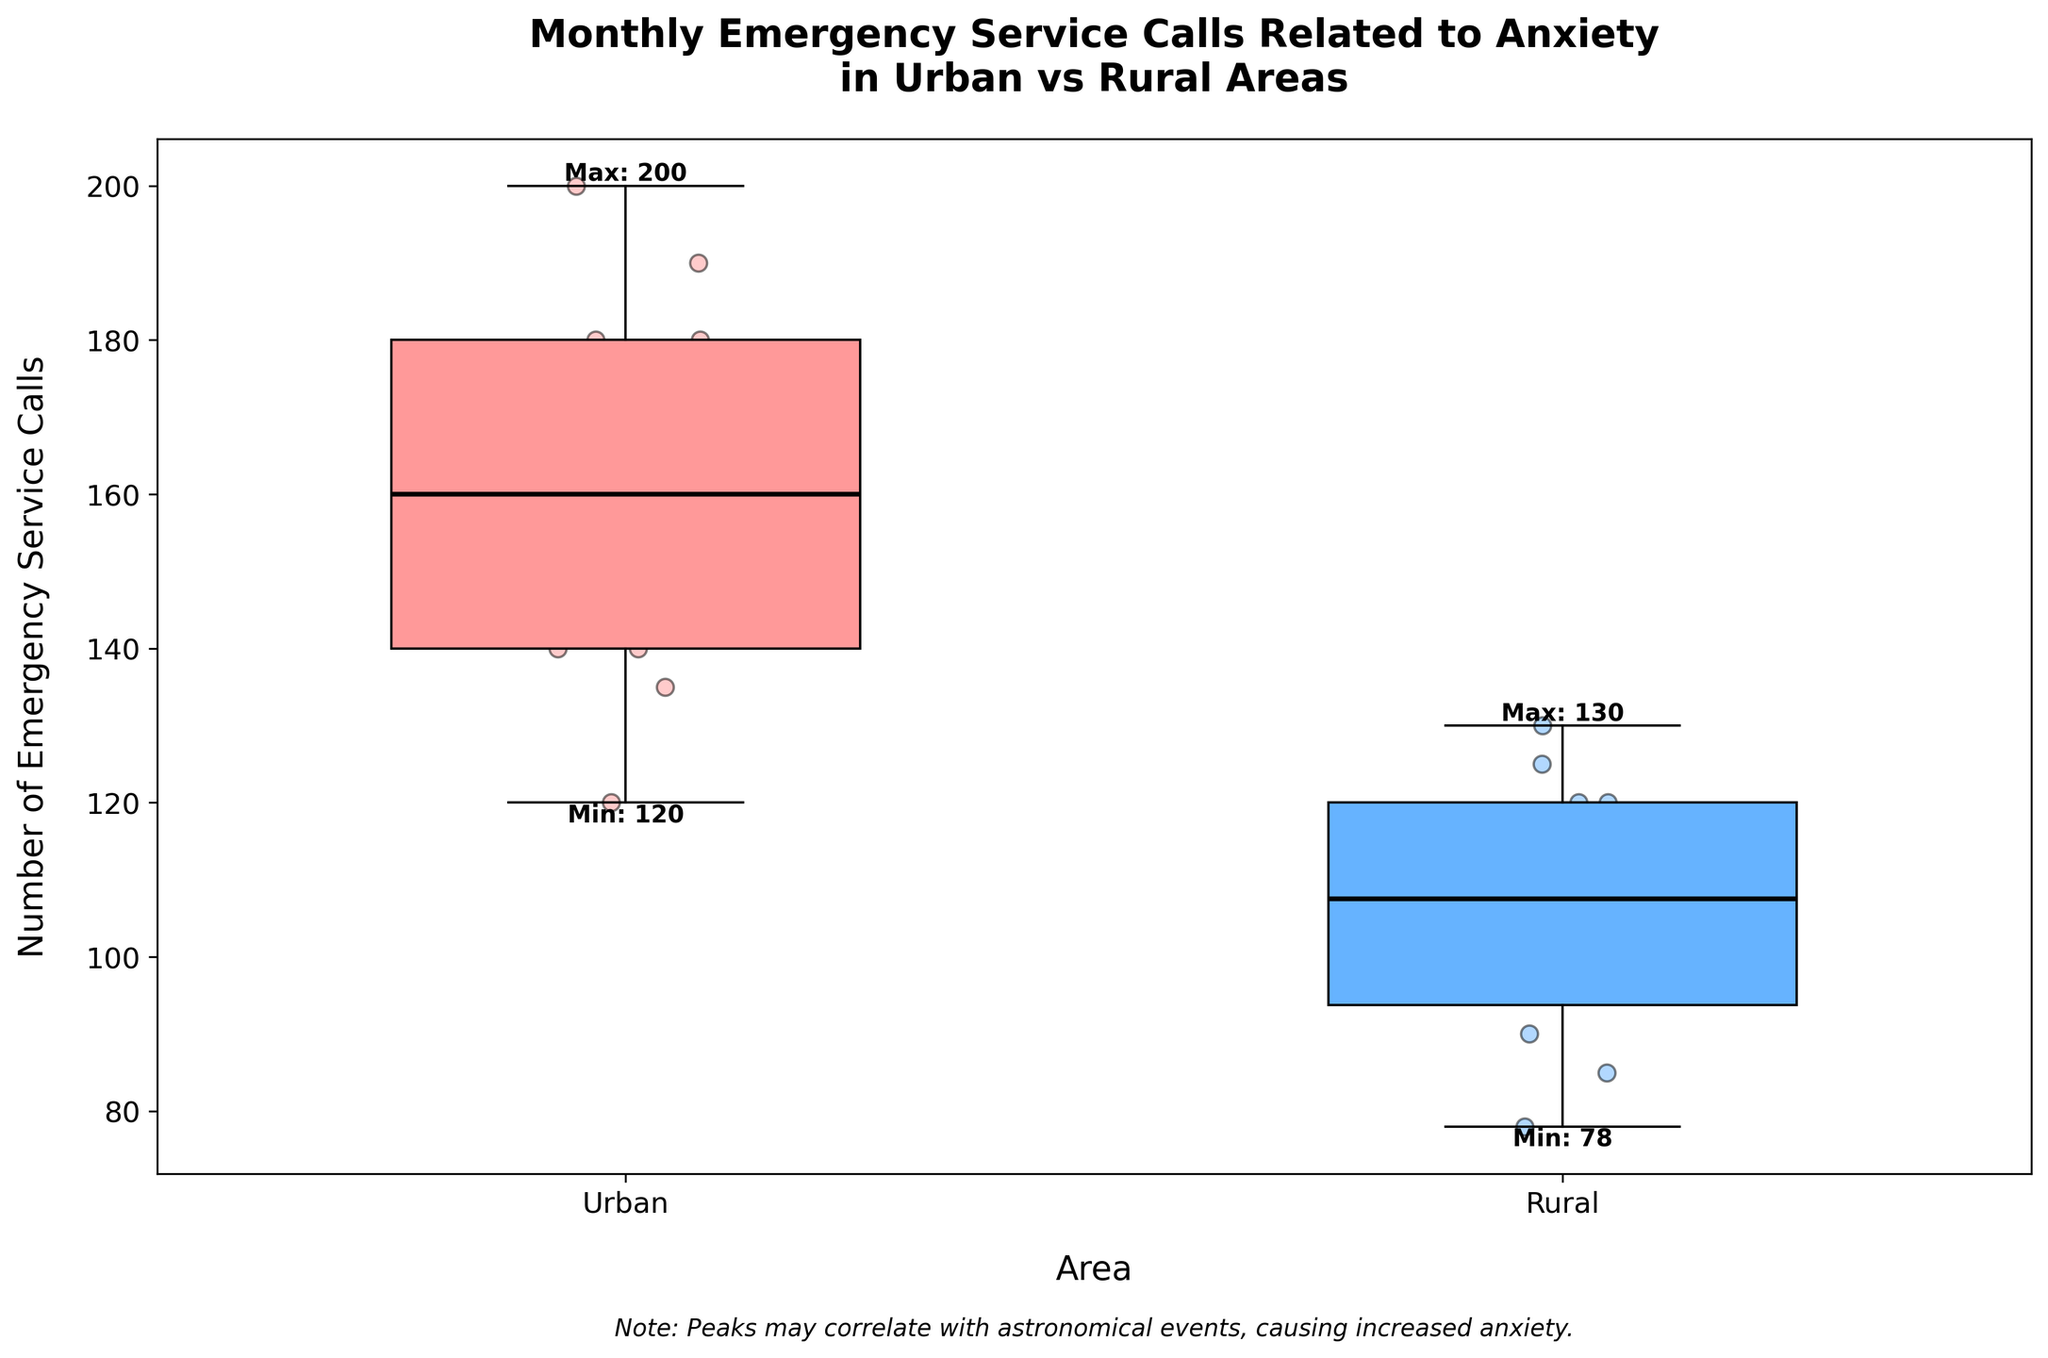what is the title of the figure? The title is the text at the top of the figure which describes its main topic. Here, it reads "Monthly Emergency Service Calls Related to Anxiety in Urban vs Rural Areas".
Answer: Monthly Emergency Service Calls Related to Anxiety in Urban vs Rural Areas What is the minimum number of emergency service calls for rural areas? The minimum number is indicated by the label at the bottom of the whisker for the rural area box plot. It shows "Min: 78".
Answer: 78 Which area shows a higher median number of emergency service calls? The median is represented by the solid line inside each box. The black line inside the box for urban areas is higher than the one for rural areas.
Answer: Urban What is the maximum number of emergency service calls in urban areas? The label at the top of the whisker for the urban area box plot indicates the maximum number, which is "Max: 200".
Answer: 200 How many months have emergency service calls exceeding 170 in urban areas? By plotting the individual data points, we can see where they fall relative to the 170 line. Data points over 170 in the urban area are noted in June, July, and August.
Answer: 3 Which month has the lowest number of emergency service calls for rural areas? By looking at the scatter points for rural areas, the lowest value of 78 appears in February.
Answer: February What is the range of emergency service calls in rural areas? The range is computed as the difference between the maximum and minimum values. Here, the rural area has a maximum of 130 and a minimum of 78, making the range 130 - 78.
Answer: 52 Does the urban area have any months with fewer emergency service calls than the highest month in rural areas? Comparing maximum values, the highest number in rural areas is 130. Urban data points below 130 are February at 120, January at 120, and December at 140 (just above). So, urban areas have months with fewer calls than the rural maximum.
Answer: Yes In which month do urban areas have the highest number of emergency service calls? The scatter points for urban areas show the highest value is 200, which occurs in August.
Answer: August What additional context does the note at the bottom of the plot provide? The note mentions that peaks in emergency service calls may correlate with astronomical events, suggesting that increased anxiety could be linked to specific astronomical events.
Answer: Peaks may correlate with astronomical events 